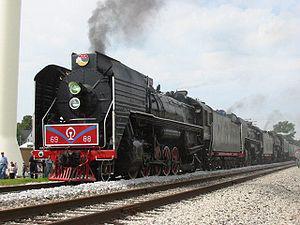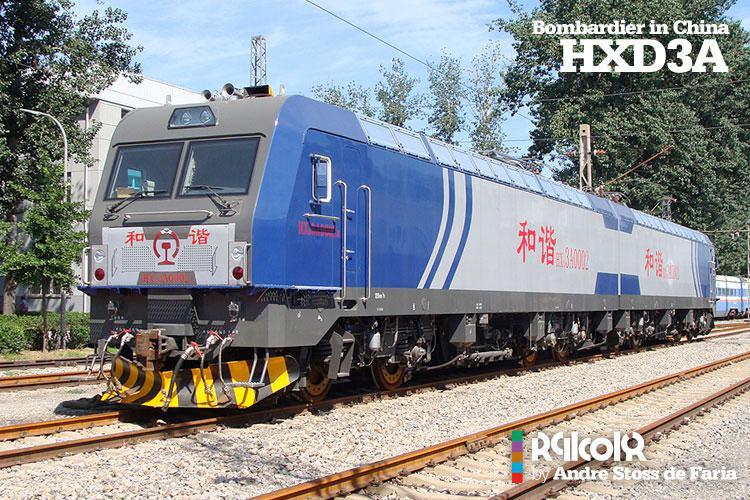The first image is the image on the left, the second image is the image on the right. Given the left and right images, does the statement "The right image contains a train that is predominately blue." hold true? Answer yes or no. Yes. The first image is the image on the left, the second image is the image on the right. Analyze the images presented: Is the assertion "The trains in the left and right images do not head in the same left or right direction, and at least one train is blue with a sloped front." valid? Answer yes or no. No. 